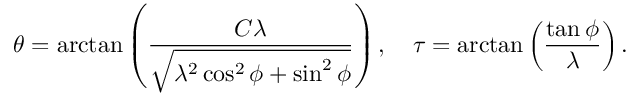<formula> <loc_0><loc_0><loc_500><loc_500>\theta = \arctan \left ( \frac { C \lambda } { \sqrt { \lambda ^ { 2 } \cos ^ { 2 } \phi + \sin ^ { 2 } \phi } } \right ) , \quad \tau = \arctan \left ( \frac { \tan \phi } { \lambda } \right ) .</formula> 